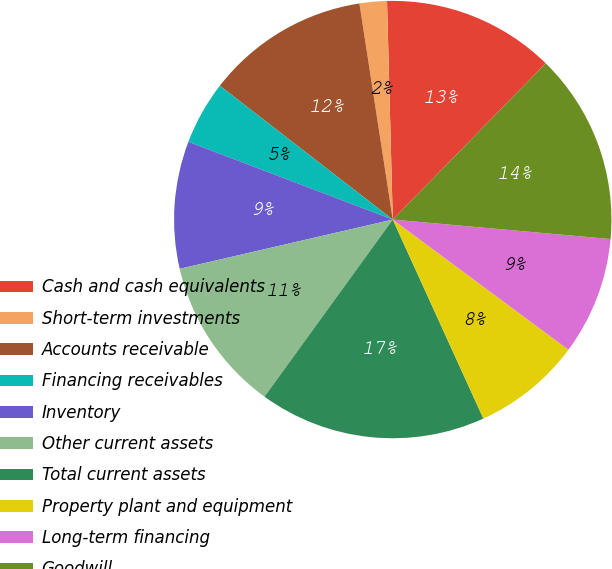Convert chart. <chart><loc_0><loc_0><loc_500><loc_500><pie_chart><fcel>Cash and cash equivalents<fcel>Short-term investments<fcel>Accounts receivable<fcel>Financing receivables<fcel>Inventory<fcel>Other current assets<fcel>Total current assets<fcel>Property plant and equipment<fcel>Long-term financing<fcel>Goodwill<nl><fcel>12.75%<fcel>2.02%<fcel>12.08%<fcel>4.7%<fcel>9.4%<fcel>11.41%<fcel>16.78%<fcel>8.05%<fcel>8.73%<fcel>14.09%<nl></chart> 